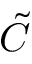<formula> <loc_0><loc_0><loc_500><loc_500>\tilde { C }</formula> 